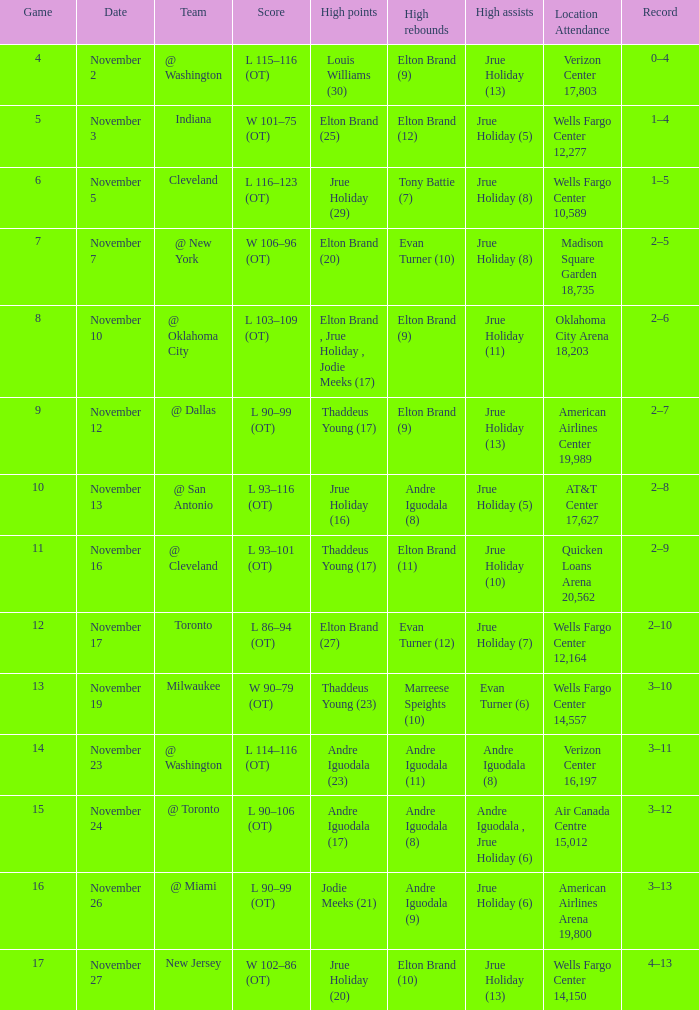What is the game number for the game with a score of l 90–106 (ot)? 15.0. 